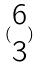<formula> <loc_0><loc_0><loc_500><loc_500>( \begin{matrix} 6 \\ 3 \end{matrix} )</formula> 